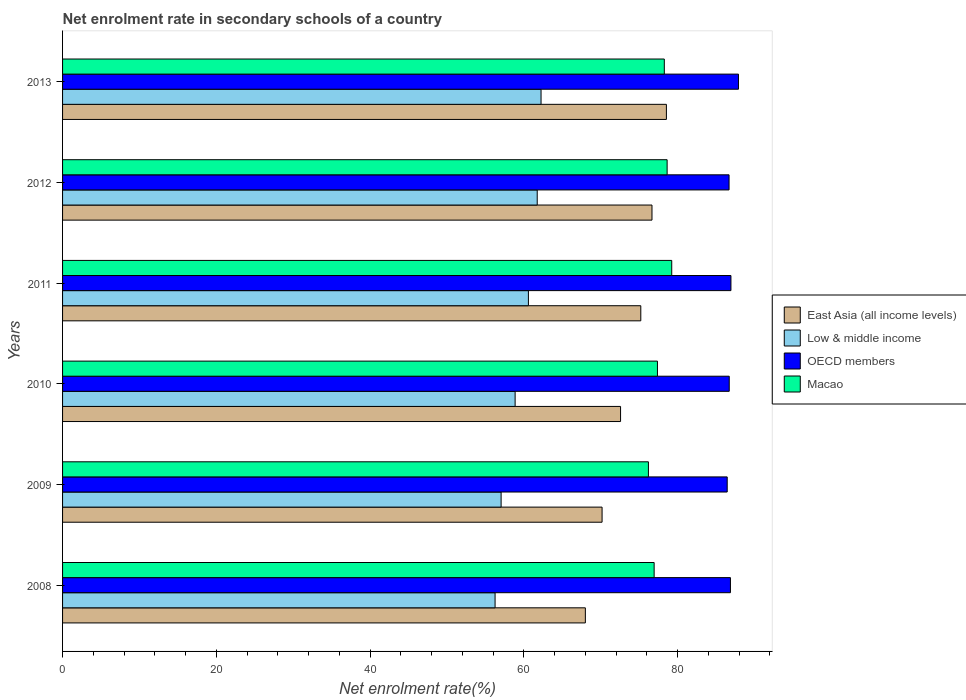Are the number of bars per tick equal to the number of legend labels?
Ensure brevity in your answer.  Yes. Are the number of bars on each tick of the Y-axis equal?
Make the answer very short. Yes. What is the net enrolment rate in secondary schools in Low & middle income in 2013?
Provide a short and direct response. 62.24. Across all years, what is the maximum net enrolment rate in secondary schools in East Asia (all income levels)?
Provide a short and direct response. 78.54. Across all years, what is the minimum net enrolment rate in secondary schools in OECD members?
Provide a short and direct response. 86.45. In which year was the net enrolment rate in secondary schools in Low & middle income maximum?
Offer a very short reply. 2013. What is the total net enrolment rate in secondary schools in East Asia (all income levels) in the graph?
Provide a succinct answer. 441.18. What is the difference between the net enrolment rate in secondary schools in Low & middle income in 2008 and that in 2012?
Make the answer very short. -5.48. What is the difference between the net enrolment rate in secondary schools in East Asia (all income levels) in 2011 and the net enrolment rate in secondary schools in Low & middle income in 2012?
Keep it short and to the point. 13.47. What is the average net enrolment rate in secondary schools in Macao per year?
Make the answer very short. 77.78. In the year 2010, what is the difference between the net enrolment rate in secondary schools in OECD members and net enrolment rate in secondary schools in East Asia (all income levels)?
Provide a succinct answer. 14.14. What is the ratio of the net enrolment rate in secondary schools in East Asia (all income levels) in 2008 to that in 2013?
Make the answer very short. 0.87. Is the difference between the net enrolment rate in secondary schools in OECD members in 2008 and 2009 greater than the difference between the net enrolment rate in secondary schools in East Asia (all income levels) in 2008 and 2009?
Give a very brief answer. Yes. What is the difference between the highest and the second highest net enrolment rate in secondary schools in Low & middle income?
Your response must be concise. 0.5. What is the difference between the highest and the lowest net enrolment rate in secondary schools in Low & middle income?
Your response must be concise. 5.98. Is the sum of the net enrolment rate in secondary schools in Low & middle income in 2011 and 2012 greater than the maximum net enrolment rate in secondary schools in East Asia (all income levels) across all years?
Your answer should be very brief. Yes. Is it the case that in every year, the sum of the net enrolment rate in secondary schools in Low & middle income and net enrolment rate in secondary schools in OECD members is greater than the sum of net enrolment rate in secondary schools in Macao and net enrolment rate in secondary schools in East Asia (all income levels)?
Ensure brevity in your answer.  Yes. What does the 1st bar from the top in 2010 represents?
Make the answer very short. Macao. What does the 3rd bar from the bottom in 2011 represents?
Provide a short and direct response. OECD members. Is it the case that in every year, the sum of the net enrolment rate in secondary schools in Low & middle income and net enrolment rate in secondary schools in East Asia (all income levels) is greater than the net enrolment rate in secondary schools in OECD members?
Give a very brief answer. Yes. How many bars are there?
Keep it short and to the point. 24. Are all the bars in the graph horizontal?
Give a very brief answer. Yes. What is the difference between two consecutive major ticks on the X-axis?
Your answer should be compact. 20. Does the graph contain any zero values?
Offer a very short reply. No. Where does the legend appear in the graph?
Offer a very short reply. Center right. What is the title of the graph?
Offer a very short reply. Net enrolment rate in secondary schools of a country. What is the label or title of the X-axis?
Make the answer very short. Net enrolment rate(%). What is the Net enrolment rate(%) in East Asia (all income levels) in 2008?
Your answer should be very brief. 68. What is the Net enrolment rate(%) in Low & middle income in 2008?
Offer a terse response. 56.26. What is the Net enrolment rate(%) in OECD members in 2008?
Provide a short and direct response. 86.87. What is the Net enrolment rate(%) in Macao in 2008?
Offer a terse response. 76.95. What is the Net enrolment rate(%) in East Asia (all income levels) in 2009?
Your response must be concise. 70.18. What is the Net enrolment rate(%) in Low & middle income in 2009?
Your answer should be very brief. 57.04. What is the Net enrolment rate(%) in OECD members in 2009?
Give a very brief answer. 86.45. What is the Net enrolment rate(%) in Macao in 2009?
Make the answer very short. 76.2. What is the Net enrolment rate(%) in East Asia (all income levels) in 2010?
Offer a terse response. 72.58. What is the Net enrolment rate(%) in Low & middle income in 2010?
Keep it short and to the point. 58.87. What is the Net enrolment rate(%) in OECD members in 2010?
Offer a terse response. 86.72. What is the Net enrolment rate(%) of Macao in 2010?
Ensure brevity in your answer.  77.38. What is the Net enrolment rate(%) of East Asia (all income levels) in 2011?
Provide a succinct answer. 75.21. What is the Net enrolment rate(%) in Low & middle income in 2011?
Keep it short and to the point. 60.59. What is the Net enrolment rate(%) in OECD members in 2011?
Provide a succinct answer. 86.94. What is the Net enrolment rate(%) in Macao in 2011?
Give a very brief answer. 79.24. What is the Net enrolment rate(%) in East Asia (all income levels) in 2012?
Your answer should be very brief. 76.67. What is the Net enrolment rate(%) in Low & middle income in 2012?
Keep it short and to the point. 61.74. What is the Net enrolment rate(%) of OECD members in 2012?
Your response must be concise. 86.69. What is the Net enrolment rate(%) of Macao in 2012?
Provide a succinct answer. 78.64. What is the Net enrolment rate(%) of East Asia (all income levels) in 2013?
Your response must be concise. 78.54. What is the Net enrolment rate(%) in Low & middle income in 2013?
Ensure brevity in your answer.  62.24. What is the Net enrolment rate(%) of OECD members in 2013?
Ensure brevity in your answer.  87.92. What is the Net enrolment rate(%) of Macao in 2013?
Give a very brief answer. 78.27. Across all years, what is the maximum Net enrolment rate(%) of East Asia (all income levels)?
Your answer should be very brief. 78.54. Across all years, what is the maximum Net enrolment rate(%) of Low & middle income?
Your answer should be very brief. 62.24. Across all years, what is the maximum Net enrolment rate(%) of OECD members?
Offer a terse response. 87.92. Across all years, what is the maximum Net enrolment rate(%) of Macao?
Provide a short and direct response. 79.24. Across all years, what is the minimum Net enrolment rate(%) of East Asia (all income levels)?
Ensure brevity in your answer.  68. Across all years, what is the minimum Net enrolment rate(%) in Low & middle income?
Ensure brevity in your answer.  56.26. Across all years, what is the minimum Net enrolment rate(%) in OECD members?
Offer a very short reply. 86.45. Across all years, what is the minimum Net enrolment rate(%) of Macao?
Give a very brief answer. 76.2. What is the total Net enrolment rate(%) of East Asia (all income levels) in the graph?
Give a very brief answer. 441.18. What is the total Net enrolment rate(%) in Low & middle income in the graph?
Offer a terse response. 356.74. What is the total Net enrolment rate(%) in OECD members in the graph?
Your answer should be compact. 521.59. What is the total Net enrolment rate(%) of Macao in the graph?
Provide a short and direct response. 466.68. What is the difference between the Net enrolment rate(%) of East Asia (all income levels) in 2008 and that in 2009?
Give a very brief answer. -2.17. What is the difference between the Net enrolment rate(%) of Low & middle income in 2008 and that in 2009?
Keep it short and to the point. -0.79. What is the difference between the Net enrolment rate(%) in OECD members in 2008 and that in 2009?
Make the answer very short. 0.42. What is the difference between the Net enrolment rate(%) in Macao in 2008 and that in 2009?
Ensure brevity in your answer.  0.74. What is the difference between the Net enrolment rate(%) in East Asia (all income levels) in 2008 and that in 2010?
Give a very brief answer. -4.58. What is the difference between the Net enrolment rate(%) in Low & middle income in 2008 and that in 2010?
Make the answer very short. -2.61. What is the difference between the Net enrolment rate(%) in OECD members in 2008 and that in 2010?
Ensure brevity in your answer.  0.16. What is the difference between the Net enrolment rate(%) in Macao in 2008 and that in 2010?
Provide a succinct answer. -0.43. What is the difference between the Net enrolment rate(%) of East Asia (all income levels) in 2008 and that in 2011?
Offer a very short reply. -7.21. What is the difference between the Net enrolment rate(%) in Low & middle income in 2008 and that in 2011?
Offer a very short reply. -4.34. What is the difference between the Net enrolment rate(%) in OECD members in 2008 and that in 2011?
Offer a very short reply. -0.07. What is the difference between the Net enrolment rate(%) in Macao in 2008 and that in 2011?
Make the answer very short. -2.29. What is the difference between the Net enrolment rate(%) of East Asia (all income levels) in 2008 and that in 2012?
Keep it short and to the point. -8.67. What is the difference between the Net enrolment rate(%) of Low & middle income in 2008 and that in 2012?
Your answer should be compact. -5.48. What is the difference between the Net enrolment rate(%) of OECD members in 2008 and that in 2012?
Provide a succinct answer. 0.18. What is the difference between the Net enrolment rate(%) of Macao in 2008 and that in 2012?
Offer a terse response. -1.69. What is the difference between the Net enrolment rate(%) of East Asia (all income levels) in 2008 and that in 2013?
Your answer should be compact. -10.54. What is the difference between the Net enrolment rate(%) of Low & middle income in 2008 and that in 2013?
Make the answer very short. -5.98. What is the difference between the Net enrolment rate(%) of OECD members in 2008 and that in 2013?
Offer a very short reply. -1.04. What is the difference between the Net enrolment rate(%) in Macao in 2008 and that in 2013?
Your answer should be compact. -1.32. What is the difference between the Net enrolment rate(%) of East Asia (all income levels) in 2009 and that in 2010?
Ensure brevity in your answer.  -2.41. What is the difference between the Net enrolment rate(%) in Low & middle income in 2009 and that in 2010?
Keep it short and to the point. -1.82. What is the difference between the Net enrolment rate(%) in OECD members in 2009 and that in 2010?
Your answer should be compact. -0.26. What is the difference between the Net enrolment rate(%) of Macao in 2009 and that in 2010?
Offer a terse response. -1.17. What is the difference between the Net enrolment rate(%) of East Asia (all income levels) in 2009 and that in 2011?
Your answer should be compact. -5.04. What is the difference between the Net enrolment rate(%) of Low & middle income in 2009 and that in 2011?
Your answer should be very brief. -3.55. What is the difference between the Net enrolment rate(%) in OECD members in 2009 and that in 2011?
Give a very brief answer. -0.49. What is the difference between the Net enrolment rate(%) of Macao in 2009 and that in 2011?
Provide a short and direct response. -3.03. What is the difference between the Net enrolment rate(%) in East Asia (all income levels) in 2009 and that in 2012?
Ensure brevity in your answer.  -6.49. What is the difference between the Net enrolment rate(%) of Low & middle income in 2009 and that in 2012?
Offer a terse response. -4.7. What is the difference between the Net enrolment rate(%) of OECD members in 2009 and that in 2012?
Give a very brief answer. -0.24. What is the difference between the Net enrolment rate(%) in Macao in 2009 and that in 2012?
Offer a terse response. -2.43. What is the difference between the Net enrolment rate(%) in East Asia (all income levels) in 2009 and that in 2013?
Your response must be concise. -8.37. What is the difference between the Net enrolment rate(%) in Low & middle income in 2009 and that in 2013?
Make the answer very short. -5.2. What is the difference between the Net enrolment rate(%) of OECD members in 2009 and that in 2013?
Your answer should be compact. -1.46. What is the difference between the Net enrolment rate(%) in Macao in 2009 and that in 2013?
Your response must be concise. -2.07. What is the difference between the Net enrolment rate(%) of East Asia (all income levels) in 2010 and that in 2011?
Your answer should be compact. -2.63. What is the difference between the Net enrolment rate(%) of Low & middle income in 2010 and that in 2011?
Offer a very short reply. -1.73. What is the difference between the Net enrolment rate(%) in OECD members in 2010 and that in 2011?
Offer a very short reply. -0.22. What is the difference between the Net enrolment rate(%) of Macao in 2010 and that in 2011?
Make the answer very short. -1.86. What is the difference between the Net enrolment rate(%) in East Asia (all income levels) in 2010 and that in 2012?
Your response must be concise. -4.09. What is the difference between the Net enrolment rate(%) of Low & middle income in 2010 and that in 2012?
Provide a succinct answer. -2.87. What is the difference between the Net enrolment rate(%) of OECD members in 2010 and that in 2012?
Your response must be concise. 0.02. What is the difference between the Net enrolment rate(%) of Macao in 2010 and that in 2012?
Provide a short and direct response. -1.26. What is the difference between the Net enrolment rate(%) in East Asia (all income levels) in 2010 and that in 2013?
Make the answer very short. -5.96. What is the difference between the Net enrolment rate(%) in Low & middle income in 2010 and that in 2013?
Give a very brief answer. -3.37. What is the difference between the Net enrolment rate(%) in OECD members in 2010 and that in 2013?
Give a very brief answer. -1.2. What is the difference between the Net enrolment rate(%) of Macao in 2010 and that in 2013?
Your response must be concise. -0.89. What is the difference between the Net enrolment rate(%) of East Asia (all income levels) in 2011 and that in 2012?
Your answer should be very brief. -1.46. What is the difference between the Net enrolment rate(%) of Low & middle income in 2011 and that in 2012?
Give a very brief answer. -1.14. What is the difference between the Net enrolment rate(%) in OECD members in 2011 and that in 2012?
Your answer should be very brief. 0.24. What is the difference between the Net enrolment rate(%) of Macao in 2011 and that in 2012?
Your response must be concise. 0.6. What is the difference between the Net enrolment rate(%) in East Asia (all income levels) in 2011 and that in 2013?
Offer a very short reply. -3.33. What is the difference between the Net enrolment rate(%) of Low & middle income in 2011 and that in 2013?
Offer a very short reply. -1.64. What is the difference between the Net enrolment rate(%) of OECD members in 2011 and that in 2013?
Ensure brevity in your answer.  -0.98. What is the difference between the Net enrolment rate(%) of Macao in 2011 and that in 2013?
Ensure brevity in your answer.  0.97. What is the difference between the Net enrolment rate(%) in East Asia (all income levels) in 2012 and that in 2013?
Keep it short and to the point. -1.88. What is the difference between the Net enrolment rate(%) in Low & middle income in 2012 and that in 2013?
Make the answer very short. -0.5. What is the difference between the Net enrolment rate(%) in OECD members in 2012 and that in 2013?
Make the answer very short. -1.22. What is the difference between the Net enrolment rate(%) in Macao in 2012 and that in 2013?
Provide a succinct answer. 0.37. What is the difference between the Net enrolment rate(%) of East Asia (all income levels) in 2008 and the Net enrolment rate(%) of Low & middle income in 2009?
Your answer should be compact. 10.96. What is the difference between the Net enrolment rate(%) in East Asia (all income levels) in 2008 and the Net enrolment rate(%) in OECD members in 2009?
Offer a terse response. -18.45. What is the difference between the Net enrolment rate(%) in East Asia (all income levels) in 2008 and the Net enrolment rate(%) in Macao in 2009?
Your answer should be compact. -8.2. What is the difference between the Net enrolment rate(%) in Low & middle income in 2008 and the Net enrolment rate(%) in OECD members in 2009?
Your answer should be compact. -30.19. What is the difference between the Net enrolment rate(%) of Low & middle income in 2008 and the Net enrolment rate(%) of Macao in 2009?
Your answer should be compact. -19.95. What is the difference between the Net enrolment rate(%) in OECD members in 2008 and the Net enrolment rate(%) in Macao in 2009?
Give a very brief answer. 10.67. What is the difference between the Net enrolment rate(%) in East Asia (all income levels) in 2008 and the Net enrolment rate(%) in Low & middle income in 2010?
Your answer should be very brief. 9.14. What is the difference between the Net enrolment rate(%) of East Asia (all income levels) in 2008 and the Net enrolment rate(%) of OECD members in 2010?
Your answer should be very brief. -18.71. What is the difference between the Net enrolment rate(%) in East Asia (all income levels) in 2008 and the Net enrolment rate(%) in Macao in 2010?
Ensure brevity in your answer.  -9.38. What is the difference between the Net enrolment rate(%) in Low & middle income in 2008 and the Net enrolment rate(%) in OECD members in 2010?
Give a very brief answer. -30.46. What is the difference between the Net enrolment rate(%) of Low & middle income in 2008 and the Net enrolment rate(%) of Macao in 2010?
Keep it short and to the point. -21.12. What is the difference between the Net enrolment rate(%) in OECD members in 2008 and the Net enrolment rate(%) in Macao in 2010?
Ensure brevity in your answer.  9.49. What is the difference between the Net enrolment rate(%) of East Asia (all income levels) in 2008 and the Net enrolment rate(%) of Low & middle income in 2011?
Your answer should be compact. 7.41. What is the difference between the Net enrolment rate(%) in East Asia (all income levels) in 2008 and the Net enrolment rate(%) in OECD members in 2011?
Your answer should be compact. -18.94. What is the difference between the Net enrolment rate(%) in East Asia (all income levels) in 2008 and the Net enrolment rate(%) in Macao in 2011?
Your answer should be compact. -11.23. What is the difference between the Net enrolment rate(%) in Low & middle income in 2008 and the Net enrolment rate(%) in OECD members in 2011?
Provide a succinct answer. -30.68. What is the difference between the Net enrolment rate(%) in Low & middle income in 2008 and the Net enrolment rate(%) in Macao in 2011?
Offer a very short reply. -22.98. What is the difference between the Net enrolment rate(%) in OECD members in 2008 and the Net enrolment rate(%) in Macao in 2011?
Give a very brief answer. 7.64. What is the difference between the Net enrolment rate(%) of East Asia (all income levels) in 2008 and the Net enrolment rate(%) of Low & middle income in 2012?
Your answer should be very brief. 6.26. What is the difference between the Net enrolment rate(%) of East Asia (all income levels) in 2008 and the Net enrolment rate(%) of OECD members in 2012?
Provide a short and direct response. -18.69. What is the difference between the Net enrolment rate(%) of East Asia (all income levels) in 2008 and the Net enrolment rate(%) of Macao in 2012?
Your answer should be very brief. -10.64. What is the difference between the Net enrolment rate(%) in Low & middle income in 2008 and the Net enrolment rate(%) in OECD members in 2012?
Provide a succinct answer. -30.44. What is the difference between the Net enrolment rate(%) in Low & middle income in 2008 and the Net enrolment rate(%) in Macao in 2012?
Provide a short and direct response. -22.38. What is the difference between the Net enrolment rate(%) in OECD members in 2008 and the Net enrolment rate(%) in Macao in 2012?
Give a very brief answer. 8.24. What is the difference between the Net enrolment rate(%) of East Asia (all income levels) in 2008 and the Net enrolment rate(%) of Low & middle income in 2013?
Your response must be concise. 5.76. What is the difference between the Net enrolment rate(%) in East Asia (all income levels) in 2008 and the Net enrolment rate(%) in OECD members in 2013?
Ensure brevity in your answer.  -19.91. What is the difference between the Net enrolment rate(%) of East Asia (all income levels) in 2008 and the Net enrolment rate(%) of Macao in 2013?
Offer a terse response. -10.27. What is the difference between the Net enrolment rate(%) in Low & middle income in 2008 and the Net enrolment rate(%) in OECD members in 2013?
Your response must be concise. -31.66. What is the difference between the Net enrolment rate(%) of Low & middle income in 2008 and the Net enrolment rate(%) of Macao in 2013?
Ensure brevity in your answer.  -22.01. What is the difference between the Net enrolment rate(%) of OECD members in 2008 and the Net enrolment rate(%) of Macao in 2013?
Your answer should be very brief. 8.6. What is the difference between the Net enrolment rate(%) in East Asia (all income levels) in 2009 and the Net enrolment rate(%) in Low & middle income in 2010?
Offer a very short reply. 11.31. What is the difference between the Net enrolment rate(%) in East Asia (all income levels) in 2009 and the Net enrolment rate(%) in OECD members in 2010?
Give a very brief answer. -16.54. What is the difference between the Net enrolment rate(%) of East Asia (all income levels) in 2009 and the Net enrolment rate(%) of Macao in 2010?
Give a very brief answer. -7.2. What is the difference between the Net enrolment rate(%) in Low & middle income in 2009 and the Net enrolment rate(%) in OECD members in 2010?
Offer a very short reply. -29.67. What is the difference between the Net enrolment rate(%) in Low & middle income in 2009 and the Net enrolment rate(%) in Macao in 2010?
Your response must be concise. -20.34. What is the difference between the Net enrolment rate(%) of OECD members in 2009 and the Net enrolment rate(%) of Macao in 2010?
Provide a succinct answer. 9.07. What is the difference between the Net enrolment rate(%) of East Asia (all income levels) in 2009 and the Net enrolment rate(%) of Low & middle income in 2011?
Offer a terse response. 9.58. What is the difference between the Net enrolment rate(%) of East Asia (all income levels) in 2009 and the Net enrolment rate(%) of OECD members in 2011?
Provide a succinct answer. -16.76. What is the difference between the Net enrolment rate(%) of East Asia (all income levels) in 2009 and the Net enrolment rate(%) of Macao in 2011?
Offer a terse response. -9.06. What is the difference between the Net enrolment rate(%) in Low & middle income in 2009 and the Net enrolment rate(%) in OECD members in 2011?
Provide a short and direct response. -29.89. What is the difference between the Net enrolment rate(%) in Low & middle income in 2009 and the Net enrolment rate(%) in Macao in 2011?
Give a very brief answer. -22.19. What is the difference between the Net enrolment rate(%) in OECD members in 2009 and the Net enrolment rate(%) in Macao in 2011?
Your response must be concise. 7.22. What is the difference between the Net enrolment rate(%) in East Asia (all income levels) in 2009 and the Net enrolment rate(%) in Low & middle income in 2012?
Your answer should be very brief. 8.44. What is the difference between the Net enrolment rate(%) of East Asia (all income levels) in 2009 and the Net enrolment rate(%) of OECD members in 2012?
Offer a very short reply. -16.52. What is the difference between the Net enrolment rate(%) in East Asia (all income levels) in 2009 and the Net enrolment rate(%) in Macao in 2012?
Your response must be concise. -8.46. What is the difference between the Net enrolment rate(%) in Low & middle income in 2009 and the Net enrolment rate(%) in OECD members in 2012?
Provide a succinct answer. -29.65. What is the difference between the Net enrolment rate(%) in Low & middle income in 2009 and the Net enrolment rate(%) in Macao in 2012?
Ensure brevity in your answer.  -21.59. What is the difference between the Net enrolment rate(%) of OECD members in 2009 and the Net enrolment rate(%) of Macao in 2012?
Keep it short and to the point. 7.82. What is the difference between the Net enrolment rate(%) in East Asia (all income levels) in 2009 and the Net enrolment rate(%) in Low & middle income in 2013?
Ensure brevity in your answer.  7.94. What is the difference between the Net enrolment rate(%) of East Asia (all income levels) in 2009 and the Net enrolment rate(%) of OECD members in 2013?
Your answer should be compact. -17.74. What is the difference between the Net enrolment rate(%) in East Asia (all income levels) in 2009 and the Net enrolment rate(%) in Macao in 2013?
Ensure brevity in your answer.  -8.1. What is the difference between the Net enrolment rate(%) of Low & middle income in 2009 and the Net enrolment rate(%) of OECD members in 2013?
Make the answer very short. -30.87. What is the difference between the Net enrolment rate(%) in Low & middle income in 2009 and the Net enrolment rate(%) in Macao in 2013?
Make the answer very short. -21.23. What is the difference between the Net enrolment rate(%) in OECD members in 2009 and the Net enrolment rate(%) in Macao in 2013?
Provide a succinct answer. 8.18. What is the difference between the Net enrolment rate(%) in East Asia (all income levels) in 2010 and the Net enrolment rate(%) in Low & middle income in 2011?
Give a very brief answer. 11.99. What is the difference between the Net enrolment rate(%) in East Asia (all income levels) in 2010 and the Net enrolment rate(%) in OECD members in 2011?
Offer a very short reply. -14.36. What is the difference between the Net enrolment rate(%) in East Asia (all income levels) in 2010 and the Net enrolment rate(%) in Macao in 2011?
Offer a very short reply. -6.66. What is the difference between the Net enrolment rate(%) in Low & middle income in 2010 and the Net enrolment rate(%) in OECD members in 2011?
Keep it short and to the point. -28.07. What is the difference between the Net enrolment rate(%) in Low & middle income in 2010 and the Net enrolment rate(%) in Macao in 2011?
Ensure brevity in your answer.  -20.37. What is the difference between the Net enrolment rate(%) of OECD members in 2010 and the Net enrolment rate(%) of Macao in 2011?
Offer a terse response. 7.48. What is the difference between the Net enrolment rate(%) of East Asia (all income levels) in 2010 and the Net enrolment rate(%) of Low & middle income in 2012?
Give a very brief answer. 10.84. What is the difference between the Net enrolment rate(%) of East Asia (all income levels) in 2010 and the Net enrolment rate(%) of OECD members in 2012?
Your answer should be compact. -14.11. What is the difference between the Net enrolment rate(%) in East Asia (all income levels) in 2010 and the Net enrolment rate(%) in Macao in 2012?
Offer a terse response. -6.06. What is the difference between the Net enrolment rate(%) in Low & middle income in 2010 and the Net enrolment rate(%) in OECD members in 2012?
Your response must be concise. -27.83. What is the difference between the Net enrolment rate(%) in Low & middle income in 2010 and the Net enrolment rate(%) in Macao in 2012?
Give a very brief answer. -19.77. What is the difference between the Net enrolment rate(%) of OECD members in 2010 and the Net enrolment rate(%) of Macao in 2012?
Offer a terse response. 8.08. What is the difference between the Net enrolment rate(%) of East Asia (all income levels) in 2010 and the Net enrolment rate(%) of Low & middle income in 2013?
Your answer should be compact. 10.34. What is the difference between the Net enrolment rate(%) of East Asia (all income levels) in 2010 and the Net enrolment rate(%) of OECD members in 2013?
Offer a terse response. -15.33. What is the difference between the Net enrolment rate(%) in East Asia (all income levels) in 2010 and the Net enrolment rate(%) in Macao in 2013?
Keep it short and to the point. -5.69. What is the difference between the Net enrolment rate(%) in Low & middle income in 2010 and the Net enrolment rate(%) in OECD members in 2013?
Offer a very short reply. -29.05. What is the difference between the Net enrolment rate(%) in Low & middle income in 2010 and the Net enrolment rate(%) in Macao in 2013?
Keep it short and to the point. -19.41. What is the difference between the Net enrolment rate(%) of OECD members in 2010 and the Net enrolment rate(%) of Macao in 2013?
Provide a short and direct response. 8.45. What is the difference between the Net enrolment rate(%) of East Asia (all income levels) in 2011 and the Net enrolment rate(%) of Low & middle income in 2012?
Offer a very short reply. 13.47. What is the difference between the Net enrolment rate(%) in East Asia (all income levels) in 2011 and the Net enrolment rate(%) in OECD members in 2012?
Your answer should be compact. -11.48. What is the difference between the Net enrolment rate(%) of East Asia (all income levels) in 2011 and the Net enrolment rate(%) of Macao in 2012?
Provide a short and direct response. -3.42. What is the difference between the Net enrolment rate(%) in Low & middle income in 2011 and the Net enrolment rate(%) in OECD members in 2012?
Your answer should be compact. -26.1. What is the difference between the Net enrolment rate(%) in Low & middle income in 2011 and the Net enrolment rate(%) in Macao in 2012?
Provide a short and direct response. -18.04. What is the difference between the Net enrolment rate(%) in OECD members in 2011 and the Net enrolment rate(%) in Macao in 2012?
Make the answer very short. 8.3. What is the difference between the Net enrolment rate(%) in East Asia (all income levels) in 2011 and the Net enrolment rate(%) in Low & middle income in 2013?
Offer a terse response. 12.97. What is the difference between the Net enrolment rate(%) of East Asia (all income levels) in 2011 and the Net enrolment rate(%) of OECD members in 2013?
Make the answer very short. -12.7. What is the difference between the Net enrolment rate(%) in East Asia (all income levels) in 2011 and the Net enrolment rate(%) in Macao in 2013?
Provide a short and direct response. -3.06. What is the difference between the Net enrolment rate(%) of Low & middle income in 2011 and the Net enrolment rate(%) of OECD members in 2013?
Make the answer very short. -27.32. What is the difference between the Net enrolment rate(%) in Low & middle income in 2011 and the Net enrolment rate(%) in Macao in 2013?
Keep it short and to the point. -17.68. What is the difference between the Net enrolment rate(%) in OECD members in 2011 and the Net enrolment rate(%) in Macao in 2013?
Ensure brevity in your answer.  8.67. What is the difference between the Net enrolment rate(%) of East Asia (all income levels) in 2012 and the Net enrolment rate(%) of Low & middle income in 2013?
Give a very brief answer. 14.43. What is the difference between the Net enrolment rate(%) of East Asia (all income levels) in 2012 and the Net enrolment rate(%) of OECD members in 2013?
Your answer should be very brief. -11.25. What is the difference between the Net enrolment rate(%) in East Asia (all income levels) in 2012 and the Net enrolment rate(%) in Macao in 2013?
Offer a very short reply. -1.6. What is the difference between the Net enrolment rate(%) in Low & middle income in 2012 and the Net enrolment rate(%) in OECD members in 2013?
Provide a short and direct response. -26.18. What is the difference between the Net enrolment rate(%) of Low & middle income in 2012 and the Net enrolment rate(%) of Macao in 2013?
Offer a very short reply. -16.53. What is the difference between the Net enrolment rate(%) of OECD members in 2012 and the Net enrolment rate(%) of Macao in 2013?
Offer a terse response. 8.42. What is the average Net enrolment rate(%) in East Asia (all income levels) per year?
Keep it short and to the point. 73.53. What is the average Net enrolment rate(%) in Low & middle income per year?
Provide a short and direct response. 59.46. What is the average Net enrolment rate(%) in OECD members per year?
Offer a very short reply. 86.93. What is the average Net enrolment rate(%) in Macao per year?
Offer a very short reply. 77.78. In the year 2008, what is the difference between the Net enrolment rate(%) of East Asia (all income levels) and Net enrolment rate(%) of Low & middle income?
Provide a succinct answer. 11.74. In the year 2008, what is the difference between the Net enrolment rate(%) in East Asia (all income levels) and Net enrolment rate(%) in OECD members?
Provide a succinct answer. -18.87. In the year 2008, what is the difference between the Net enrolment rate(%) in East Asia (all income levels) and Net enrolment rate(%) in Macao?
Make the answer very short. -8.95. In the year 2008, what is the difference between the Net enrolment rate(%) in Low & middle income and Net enrolment rate(%) in OECD members?
Give a very brief answer. -30.61. In the year 2008, what is the difference between the Net enrolment rate(%) of Low & middle income and Net enrolment rate(%) of Macao?
Offer a very short reply. -20.69. In the year 2008, what is the difference between the Net enrolment rate(%) of OECD members and Net enrolment rate(%) of Macao?
Your response must be concise. 9.92. In the year 2009, what is the difference between the Net enrolment rate(%) of East Asia (all income levels) and Net enrolment rate(%) of Low & middle income?
Provide a succinct answer. 13.13. In the year 2009, what is the difference between the Net enrolment rate(%) of East Asia (all income levels) and Net enrolment rate(%) of OECD members?
Your answer should be very brief. -16.28. In the year 2009, what is the difference between the Net enrolment rate(%) in East Asia (all income levels) and Net enrolment rate(%) in Macao?
Keep it short and to the point. -6.03. In the year 2009, what is the difference between the Net enrolment rate(%) in Low & middle income and Net enrolment rate(%) in OECD members?
Offer a terse response. -29.41. In the year 2009, what is the difference between the Net enrolment rate(%) in Low & middle income and Net enrolment rate(%) in Macao?
Keep it short and to the point. -19.16. In the year 2009, what is the difference between the Net enrolment rate(%) in OECD members and Net enrolment rate(%) in Macao?
Your answer should be very brief. 10.25. In the year 2010, what is the difference between the Net enrolment rate(%) in East Asia (all income levels) and Net enrolment rate(%) in Low & middle income?
Give a very brief answer. 13.72. In the year 2010, what is the difference between the Net enrolment rate(%) of East Asia (all income levels) and Net enrolment rate(%) of OECD members?
Your answer should be compact. -14.14. In the year 2010, what is the difference between the Net enrolment rate(%) of East Asia (all income levels) and Net enrolment rate(%) of Macao?
Make the answer very short. -4.8. In the year 2010, what is the difference between the Net enrolment rate(%) in Low & middle income and Net enrolment rate(%) in OECD members?
Make the answer very short. -27.85. In the year 2010, what is the difference between the Net enrolment rate(%) of Low & middle income and Net enrolment rate(%) of Macao?
Provide a short and direct response. -18.51. In the year 2010, what is the difference between the Net enrolment rate(%) in OECD members and Net enrolment rate(%) in Macao?
Your response must be concise. 9.34. In the year 2011, what is the difference between the Net enrolment rate(%) of East Asia (all income levels) and Net enrolment rate(%) of Low & middle income?
Keep it short and to the point. 14.62. In the year 2011, what is the difference between the Net enrolment rate(%) of East Asia (all income levels) and Net enrolment rate(%) of OECD members?
Your answer should be compact. -11.73. In the year 2011, what is the difference between the Net enrolment rate(%) of East Asia (all income levels) and Net enrolment rate(%) of Macao?
Make the answer very short. -4.02. In the year 2011, what is the difference between the Net enrolment rate(%) of Low & middle income and Net enrolment rate(%) of OECD members?
Provide a succinct answer. -26.34. In the year 2011, what is the difference between the Net enrolment rate(%) of Low & middle income and Net enrolment rate(%) of Macao?
Your answer should be very brief. -18.64. In the year 2011, what is the difference between the Net enrolment rate(%) of OECD members and Net enrolment rate(%) of Macao?
Give a very brief answer. 7.7. In the year 2012, what is the difference between the Net enrolment rate(%) of East Asia (all income levels) and Net enrolment rate(%) of Low & middle income?
Provide a short and direct response. 14.93. In the year 2012, what is the difference between the Net enrolment rate(%) in East Asia (all income levels) and Net enrolment rate(%) in OECD members?
Make the answer very short. -10.03. In the year 2012, what is the difference between the Net enrolment rate(%) in East Asia (all income levels) and Net enrolment rate(%) in Macao?
Offer a very short reply. -1.97. In the year 2012, what is the difference between the Net enrolment rate(%) of Low & middle income and Net enrolment rate(%) of OECD members?
Your answer should be compact. -24.95. In the year 2012, what is the difference between the Net enrolment rate(%) of Low & middle income and Net enrolment rate(%) of Macao?
Offer a terse response. -16.9. In the year 2012, what is the difference between the Net enrolment rate(%) of OECD members and Net enrolment rate(%) of Macao?
Give a very brief answer. 8.06. In the year 2013, what is the difference between the Net enrolment rate(%) of East Asia (all income levels) and Net enrolment rate(%) of Low & middle income?
Your answer should be very brief. 16.31. In the year 2013, what is the difference between the Net enrolment rate(%) of East Asia (all income levels) and Net enrolment rate(%) of OECD members?
Provide a succinct answer. -9.37. In the year 2013, what is the difference between the Net enrolment rate(%) in East Asia (all income levels) and Net enrolment rate(%) in Macao?
Offer a very short reply. 0.27. In the year 2013, what is the difference between the Net enrolment rate(%) of Low & middle income and Net enrolment rate(%) of OECD members?
Your response must be concise. -25.68. In the year 2013, what is the difference between the Net enrolment rate(%) in Low & middle income and Net enrolment rate(%) in Macao?
Offer a terse response. -16.03. In the year 2013, what is the difference between the Net enrolment rate(%) of OECD members and Net enrolment rate(%) of Macao?
Provide a succinct answer. 9.65. What is the ratio of the Net enrolment rate(%) of Low & middle income in 2008 to that in 2009?
Offer a very short reply. 0.99. What is the ratio of the Net enrolment rate(%) of OECD members in 2008 to that in 2009?
Keep it short and to the point. 1. What is the ratio of the Net enrolment rate(%) of Macao in 2008 to that in 2009?
Make the answer very short. 1.01. What is the ratio of the Net enrolment rate(%) in East Asia (all income levels) in 2008 to that in 2010?
Your answer should be compact. 0.94. What is the ratio of the Net enrolment rate(%) of Low & middle income in 2008 to that in 2010?
Your answer should be compact. 0.96. What is the ratio of the Net enrolment rate(%) in OECD members in 2008 to that in 2010?
Offer a very short reply. 1. What is the ratio of the Net enrolment rate(%) of Macao in 2008 to that in 2010?
Keep it short and to the point. 0.99. What is the ratio of the Net enrolment rate(%) in East Asia (all income levels) in 2008 to that in 2011?
Your answer should be very brief. 0.9. What is the ratio of the Net enrolment rate(%) of Low & middle income in 2008 to that in 2011?
Provide a succinct answer. 0.93. What is the ratio of the Net enrolment rate(%) of Macao in 2008 to that in 2011?
Your response must be concise. 0.97. What is the ratio of the Net enrolment rate(%) in East Asia (all income levels) in 2008 to that in 2012?
Offer a terse response. 0.89. What is the ratio of the Net enrolment rate(%) of Low & middle income in 2008 to that in 2012?
Ensure brevity in your answer.  0.91. What is the ratio of the Net enrolment rate(%) of OECD members in 2008 to that in 2012?
Your response must be concise. 1. What is the ratio of the Net enrolment rate(%) in Macao in 2008 to that in 2012?
Your answer should be very brief. 0.98. What is the ratio of the Net enrolment rate(%) of East Asia (all income levels) in 2008 to that in 2013?
Offer a terse response. 0.87. What is the ratio of the Net enrolment rate(%) of Low & middle income in 2008 to that in 2013?
Give a very brief answer. 0.9. What is the ratio of the Net enrolment rate(%) in OECD members in 2008 to that in 2013?
Your answer should be compact. 0.99. What is the ratio of the Net enrolment rate(%) in Macao in 2008 to that in 2013?
Ensure brevity in your answer.  0.98. What is the ratio of the Net enrolment rate(%) in East Asia (all income levels) in 2009 to that in 2010?
Ensure brevity in your answer.  0.97. What is the ratio of the Net enrolment rate(%) of Macao in 2009 to that in 2010?
Provide a succinct answer. 0.98. What is the ratio of the Net enrolment rate(%) in East Asia (all income levels) in 2009 to that in 2011?
Your answer should be compact. 0.93. What is the ratio of the Net enrolment rate(%) of Low & middle income in 2009 to that in 2011?
Provide a short and direct response. 0.94. What is the ratio of the Net enrolment rate(%) of Macao in 2009 to that in 2011?
Your answer should be very brief. 0.96. What is the ratio of the Net enrolment rate(%) in East Asia (all income levels) in 2009 to that in 2012?
Keep it short and to the point. 0.92. What is the ratio of the Net enrolment rate(%) of Low & middle income in 2009 to that in 2012?
Your answer should be compact. 0.92. What is the ratio of the Net enrolment rate(%) in Macao in 2009 to that in 2012?
Provide a succinct answer. 0.97. What is the ratio of the Net enrolment rate(%) in East Asia (all income levels) in 2009 to that in 2013?
Make the answer very short. 0.89. What is the ratio of the Net enrolment rate(%) in Low & middle income in 2009 to that in 2013?
Give a very brief answer. 0.92. What is the ratio of the Net enrolment rate(%) in OECD members in 2009 to that in 2013?
Provide a succinct answer. 0.98. What is the ratio of the Net enrolment rate(%) of Macao in 2009 to that in 2013?
Make the answer very short. 0.97. What is the ratio of the Net enrolment rate(%) of Low & middle income in 2010 to that in 2011?
Provide a succinct answer. 0.97. What is the ratio of the Net enrolment rate(%) in Macao in 2010 to that in 2011?
Keep it short and to the point. 0.98. What is the ratio of the Net enrolment rate(%) of East Asia (all income levels) in 2010 to that in 2012?
Provide a short and direct response. 0.95. What is the ratio of the Net enrolment rate(%) in Low & middle income in 2010 to that in 2012?
Your response must be concise. 0.95. What is the ratio of the Net enrolment rate(%) in East Asia (all income levels) in 2010 to that in 2013?
Your response must be concise. 0.92. What is the ratio of the Net enrolment rate(%) in Low & middle income in 2010 to that in 2013?
Your response must be concise. 0.95. What is the ratio of the Net enrolment rate(%) of OECD members in 2010 to that in 2013?
Make the answer very short. 0.99. What is the ratio of the Net enrolment rate(%) in East Asia (all income levels) in 2011 to that in 2012?
Provide a short and direct response. 0.98. What is the ratio of the Net enrolment rate(%) in Low & middle income in 2011 to that in 2012?
Offer a terse response. 0.98. What is the ratio of the Net enrolment rate(%) of Macao in 2011 to that in 2012?
Ensure brevity in your answer.  1.01. What is the ratio of the Net enrolment rate(%) in East Asia (all income levels) in 2011 to that in 2013?
Provide a succinct answer. 0.96. What is the ratio of the Net enrolment rate(%) in Low & middle income in 2011 to that in 2013?
Provide a succinct answer. 0.97. What is the ratio of the Net enrolment rate(%) in OECD members in 2011 to that in 2013?
Your response must be concise. 0.99. What is the ratio of the Net enrolment rate(%) of Macao in 2011 to that in 2013?
Offer a terse response. 1.01. What is the ratio of the Net enrolment rate(%) of East Asia (all income levels) in 2012 to that in 2013?
Keep it short and to the point. 0.98. What is the ratio of the Net enrolment rate(%) in Low & middle income in 2012 to that in 2013?
Keep it short and to the point. 0.99. What is the ratio of the Net enrolment rate(%) in OECD members in 2012 to that in 2013?
Offer a terse response. 0.99. What is the difference between the highest and the second highest Net enrolment rate(%) of East Asia (all income levels)?
Give a very brief answer. 1.88. What is the difference between the highest and the second highest Net enrolment rate(%) of Low & middle income?
Offer a very short reply. 0.5. What is the difference between the highest and the second highest Net enrolment rate(%) of OECD members?
Provide a short and direct response. 0.98. What is the difference between the highest and the second highest Net enrolment rate(%) of Macao?
Your answer should be compact. 0.6. What is the difference between the highest and the lowest Net enrolment rate(%) in East Asia (all income levels)?
Keep it short and to the point. 10.54. What is the difference between the highest and the lowest Net enrolment rate(%) of Low & middle income?
Provide a succinct answer. 5.98. What is the difference between the highest and the lowest Net enrolment rate(%) in OECD members?
Your response must be concise. 1.46. What is the difference between the highest and the lowest Net enrolment rate(%) in Macao?
Your answer should be compact. 3.03. 